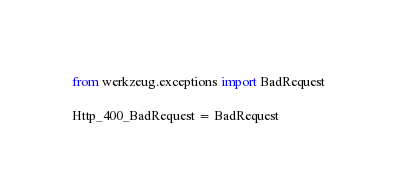<code> <loc_0><loc_0><loc_500><loc_500><_Python_>from werkzeug.exceptions import BadRequest

Http_400_BadRequest = BadRequest
</code> 